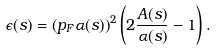Convert formula to latex. <formula><loc_0><loc_0><loc_500><loc_500>\epsilon ( s ) = \left ( p _ { F } \alpha ( s ) \right ) ^ { 2 } \left ( 2 \frac { A ( s ) } { \alpha ( s ) } - 1 \right ) .</formula> 